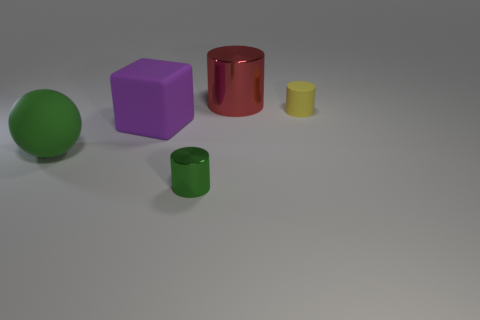What is the material of the tiny yellow thing that is the same shape as the large red thing?
Ensure brevity in your answer.  Rubber. There is a object that is both on the right side of the large rubber sphere and left of the tiny shiny object; what shape is it?
Your response must be concise. Cube. There is a tiny cylinder that is to the right of the green metal cylinder; what number of things are on the left side of it?
Ensure brevity in your answer.  4. Are there any other things that have the same material as the purple thing?
Ensure brevity in your answer.  Yes. What number of things are either metal things that are in front of the matte cylinder or green shiny cylinders?
Offer a terse response. 1. There is a thing behind the yellow matte thing; what is its size?
Your response must be concise. Large. What material is the big sphere?
Ensure brevity in your answer.  Rubber. What shape is the matte thing right of the cylinder in front of the tiny yellow cylinder?
Your answer should be very brief. Cylinder. What number of other things are the same shape as the big metal thing?
Provide a short and direct response. 2. Are there any large red cylinders in front of the cube?
Your answer should be compact. No. 